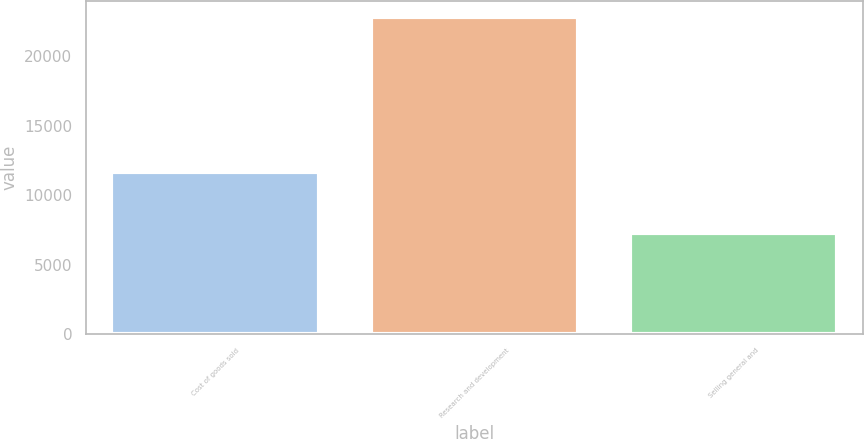<chart> <loc_0><loc_0><loc_500><loc_500><bar_chart><fcel>Cost of goods sold<fcel>Research and development<fcel>Selling general and<nl><fcel>11668<fcel>22799<fcel>7249<nl></chart> 